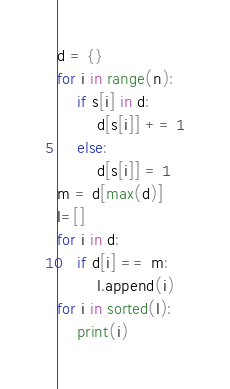<code> <loc_0><loc_0><loc_500><loc_500><_Python_>d = {}
for i in range(n):
    if s[i] in d:
        d[s[i]] += 1
    else:
        d[s[i]] = 1
m = d[max(d)]
l=[]
for i in d:
    if d[i] == m:
        l.append(i)
for i in sorted(l):
    print(i)</code> 